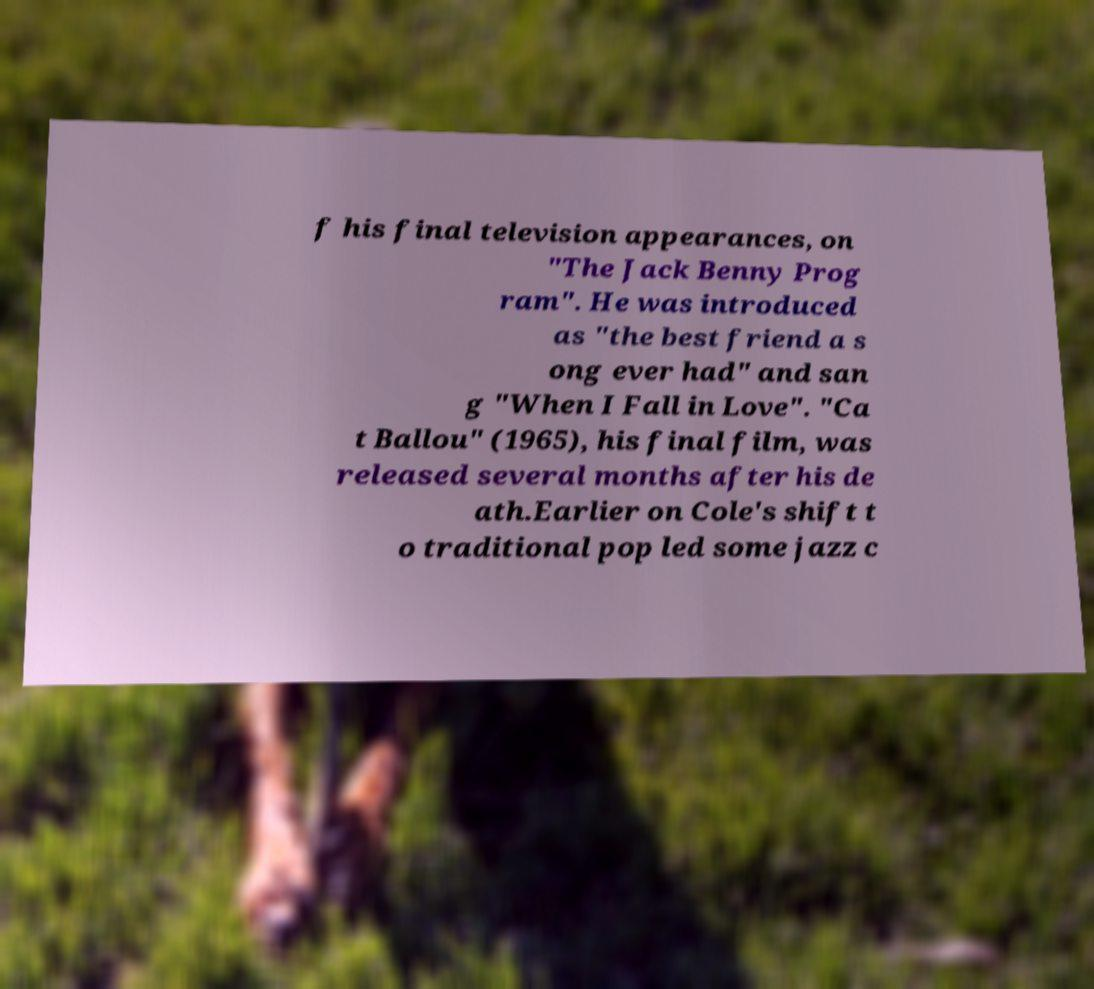Can you read and provide the text displayed in the image?This photo seems to have some interesting text. Can you extract and type it out for me? f his final television appearances, on "The Jack Benny Prog ram". He was introduced as "the best friend a s ong ever had" and san g "When I Fall in Love". "Ca t Ballou" (1965), his final film, was released several months after his de ath.Earlier on Cole's shift t o traditional pop led some jazz c 